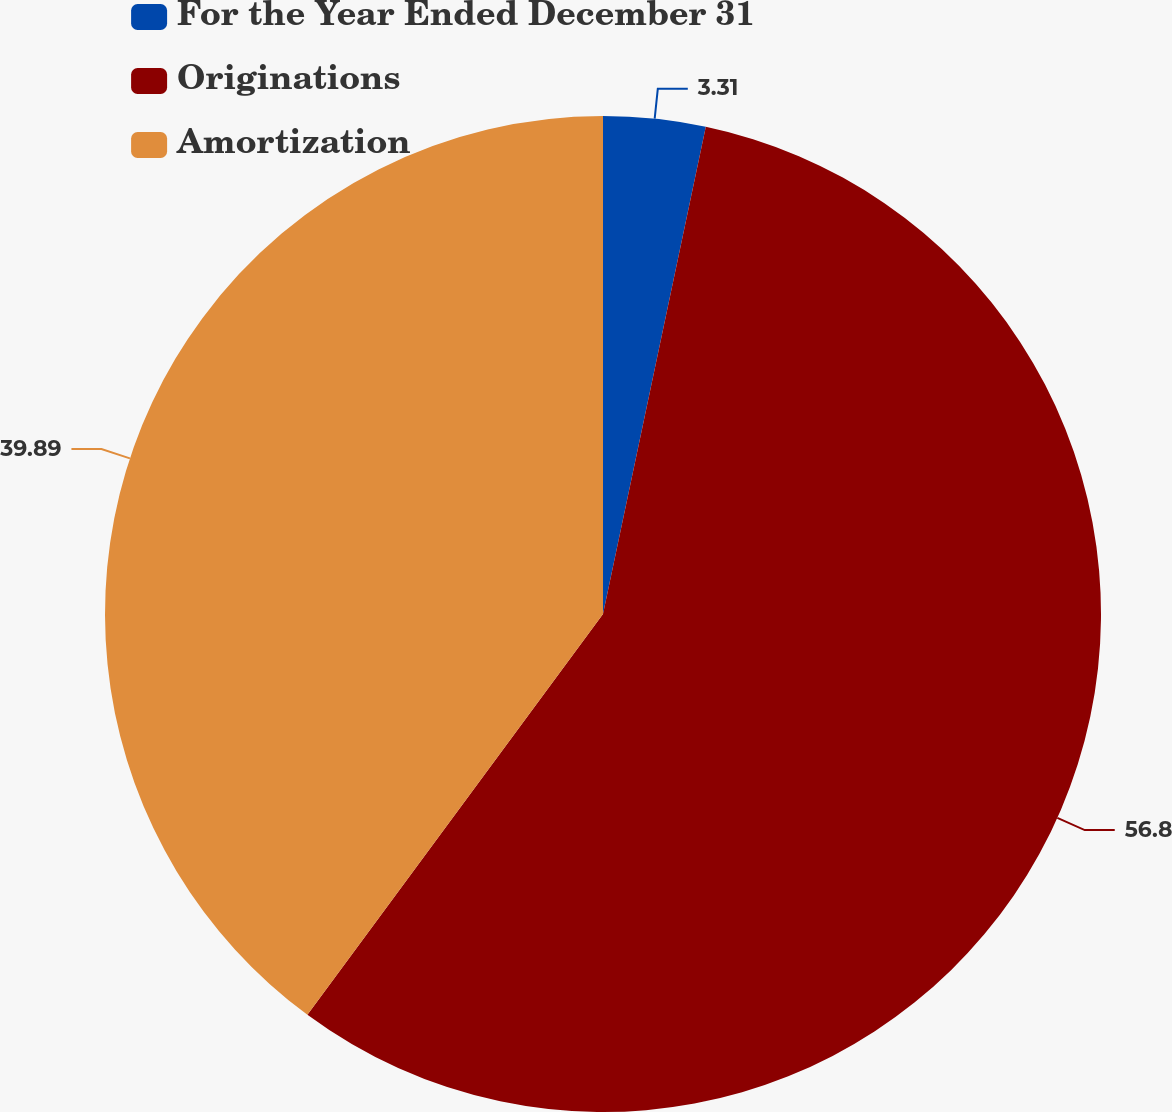Convert chart to OTSL. <chart><loc_0><loc_0><loc_500><loc_500><pie_chart><fcel>For the Year Ended December 31<fcel>Originations<fcel>Amortization<nl><fcel>3.31%<fcel>56.81%<fcel>39.89%<nl></chart> 